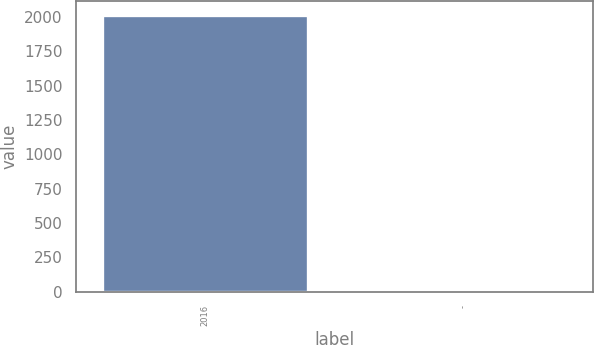<chart> <loc_0><loc_0><loc_500><loc_500><bar_chart><fcel>2016<fcel>-<nl><fcel>2015<fcel>0.9<nl></chart> 